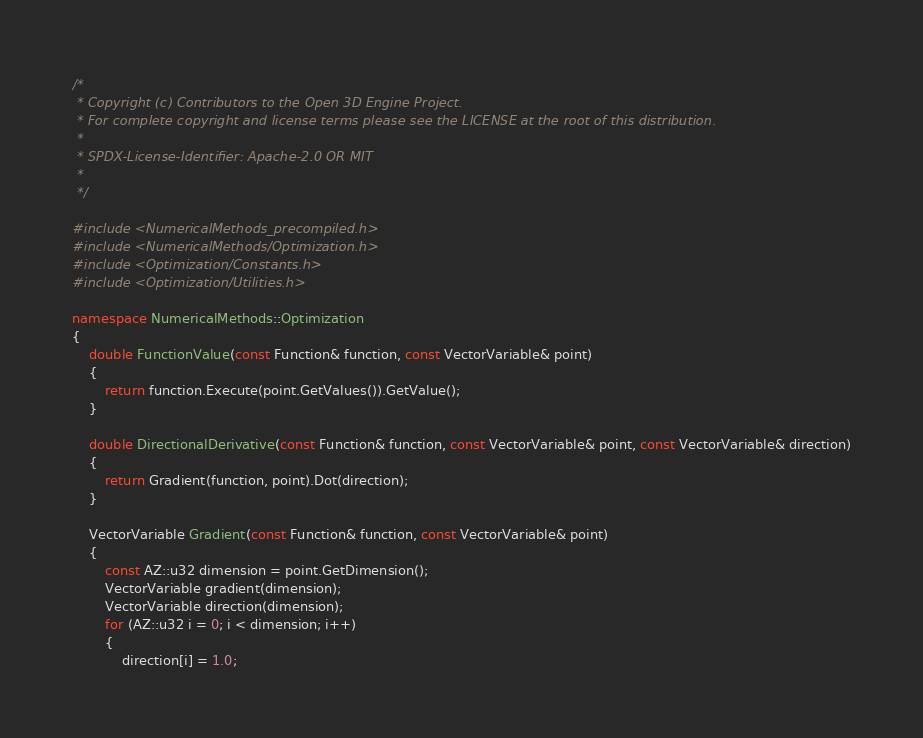Convert code to text. <code><loc_0><loc_0><loc_500><loc_500><_C++_>/*
 * Copyright (c) Contributors to the Open 3D Engine Project.
 * For complete copyright and license terms please see the LICENSE at the root of this distribution.
 *
 * SPDX-License-Identifier: Apache-2.0 OR MIT
 *
 */

#include <NumericalMethods_precompiled.h>
#include <NumericalMethods/Optimization.h>
#include <Optimization/Constants.h>
#include <Optimization/Utilities.h>

namespace NumericalMethods::Optimization
{
    double FunctionValue(const Function& function, const VectorVariable& point)
    {
        return function.Execute(point.GetValues()).GetValue();
    }

    double DirectionalDerivative(const Function& function, const VectorVariable& point, const VectorVariable& direction)
    {
        return Gradient(function, point).Dot(direction);
    }

    VectorVariable Gradient(const Function& function, const VectorVariable& point)
    {
        const AZ::u32 dimension = point.GetDimension();
        VectorVariable gradient(dimension);
        VectorVariable direction(dimension);
        for (AZ::u32 i = 0; i < dimension; i++)
        {
            direction[i] = 1.0;</code> 